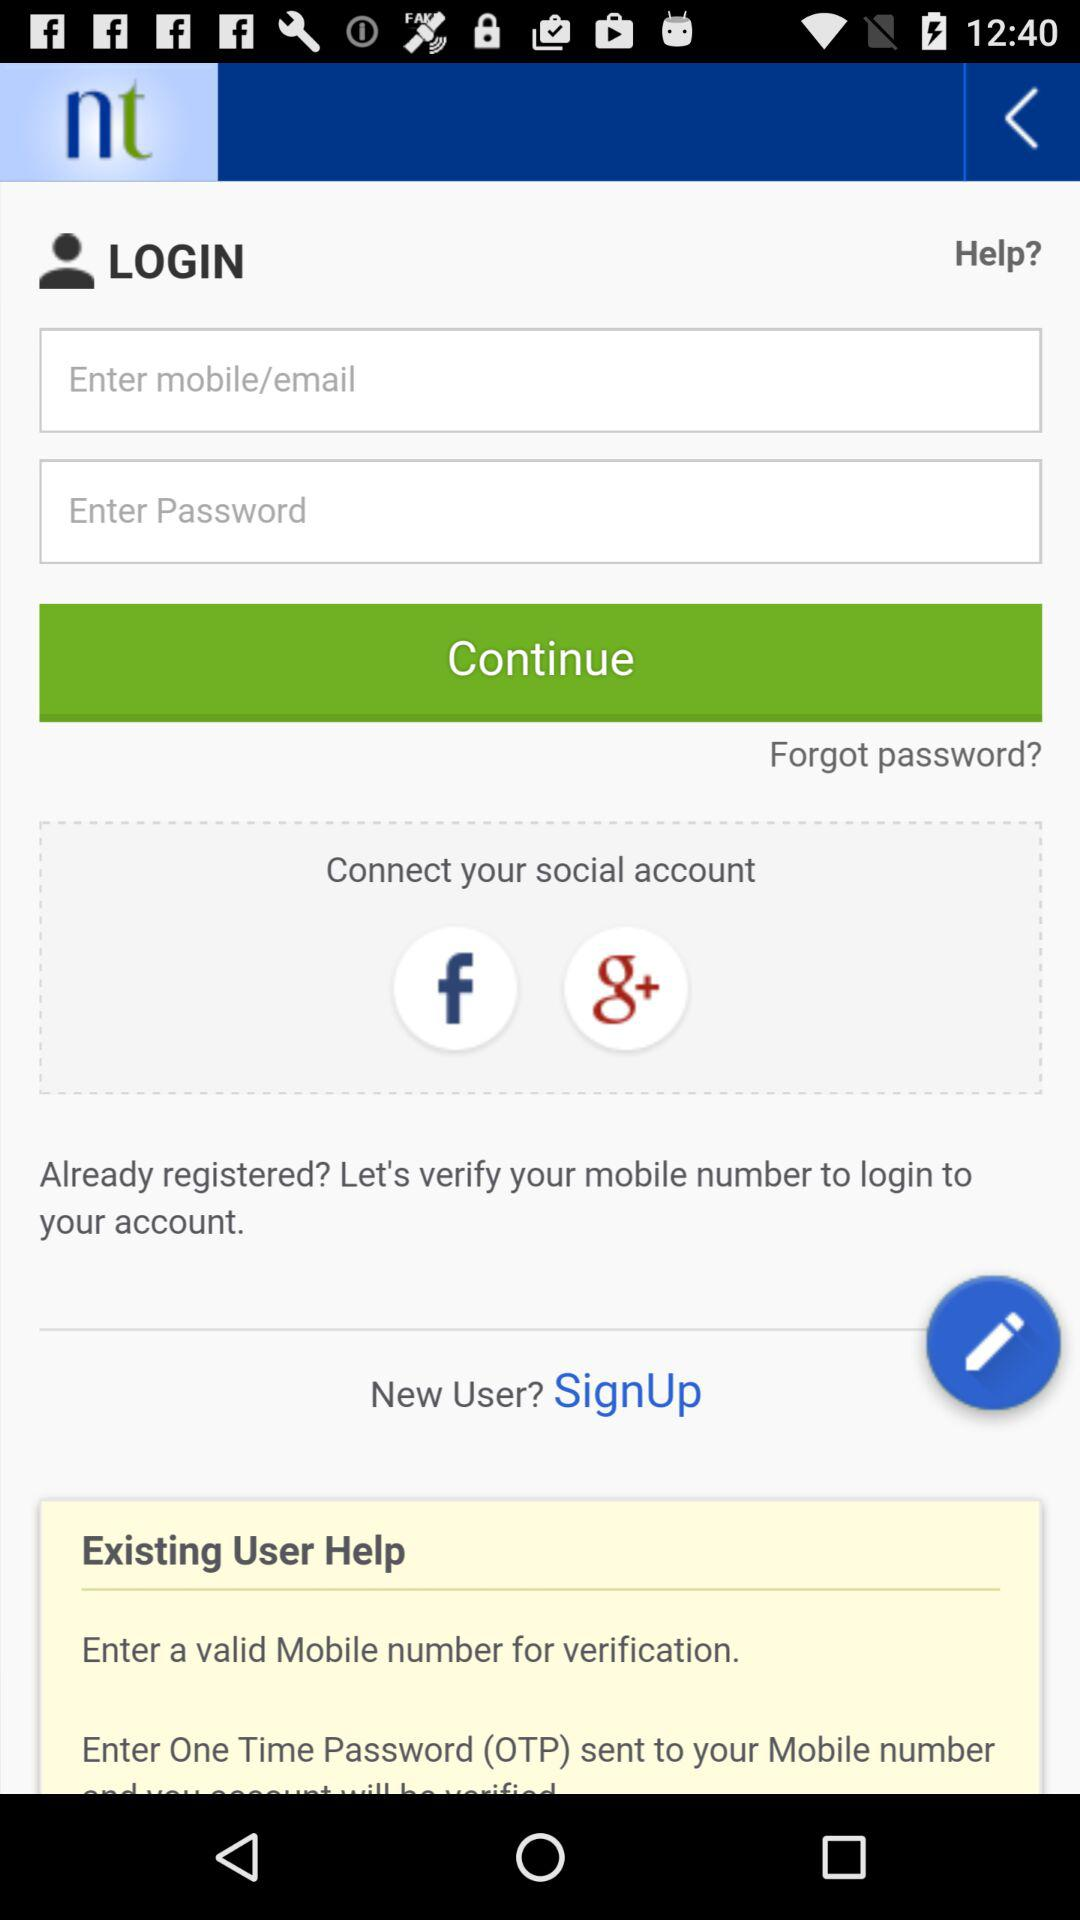How many 'Enter' labels are there on the screen?
Answer the question using a single word or phrase. 2 